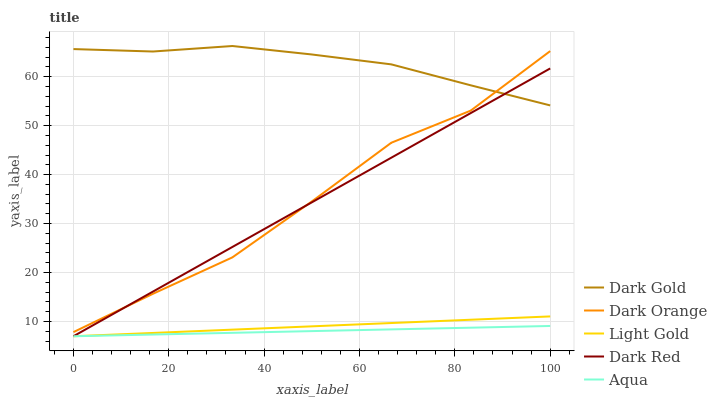Does Aqua have the minimum area under the curve?
Answer yes or no. Yes. Does Dark Gold have the maximum area under the curve?
Answer yes or no. Yes. Does Dark Orange have the minimum area under the curve?
Answer yes or no. No. Does Dark Orange have the maximum area under the curve?
Answer yes or no. No. Is Light Gold the smoothest?
Answer yes or no. Yes. Is Dark Orange the roughest?
Answer yes or no. Yes. Is Dark Red the smoothest?
Answer yes or no. No. Is Dark Red the roughest?
Answer yes or no. No. Does Aqua have the lowest value?
Answer yes or no. Yes. Does Dark Orange have the lowest value?
Answer yes or no. No. Does Dark Gold have the highest value?
Answer yes or no. Yes. Does Dark Orange have the highest value?
Answer yes or no. No. Is Aqua less than Dark Gold?
Answer yes or no. Yes. Is Dark Gold greater than Aqua?
Answer yes or no. Yes. Does Dark Red intersect Dark Gold?
Answer yes or no. Yes. Is Dark Red less than Dark Gold?
Answer yes or no. No. Is Dark Red greater than Dark Gold?
Answer yes or no. No. Does Aqua intersect Dark Gold?
Answer yes or no. No. 